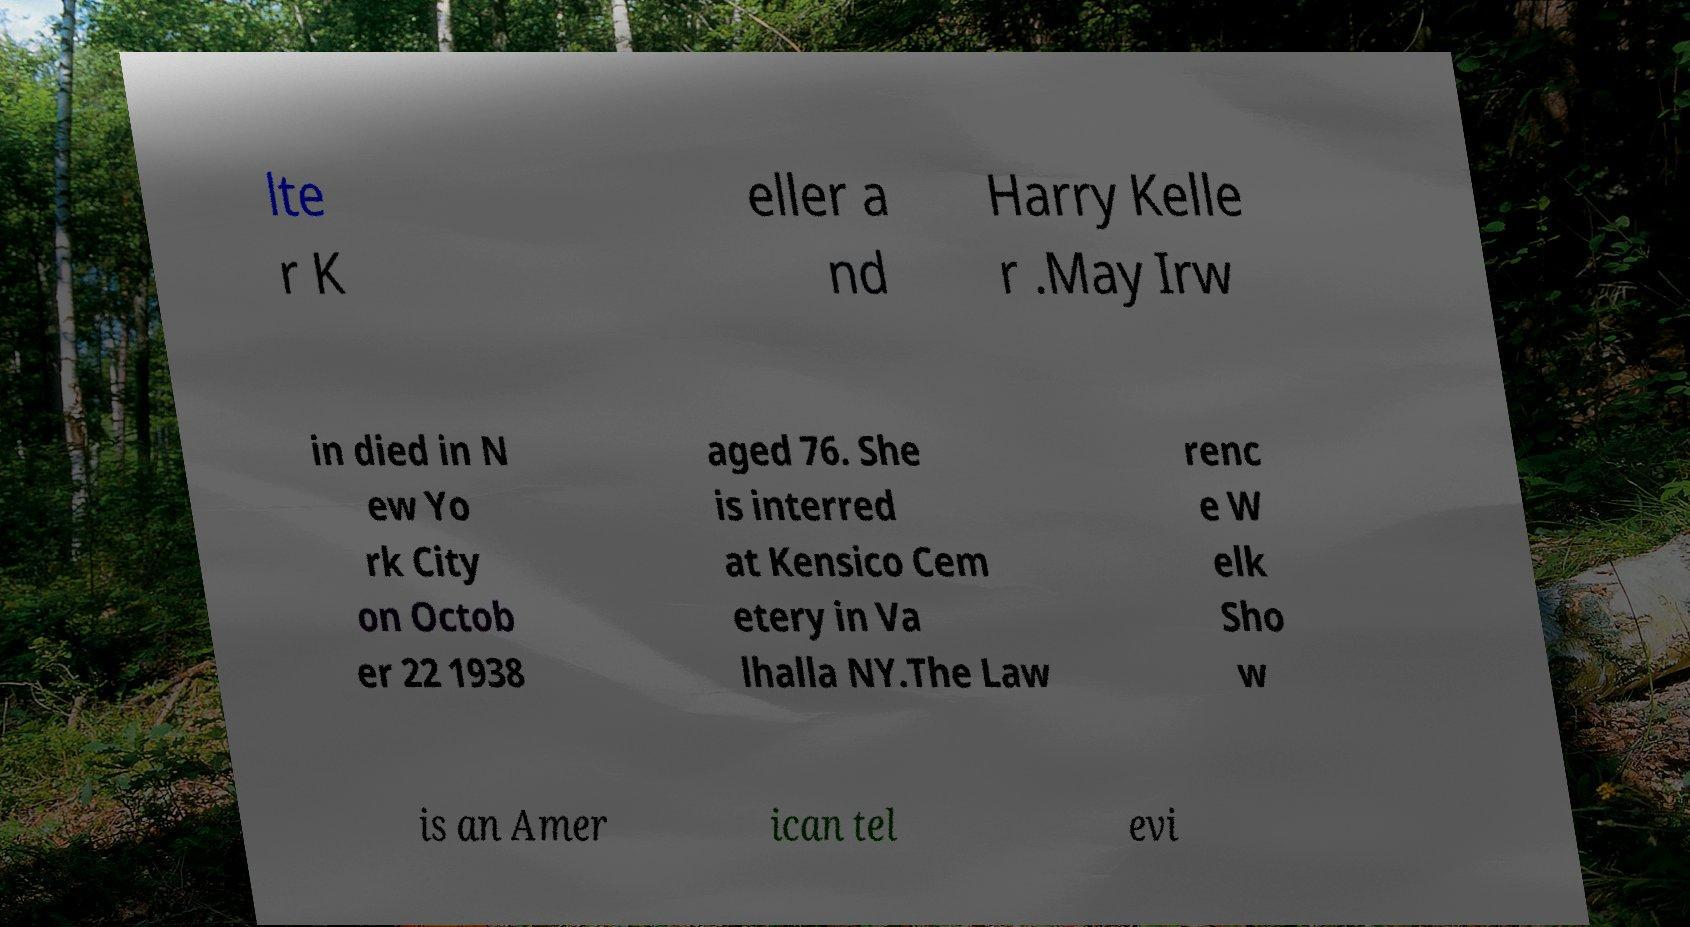What messages or text are displayed in this image? I need them in a readable, typed format. lte r K eller a nd Harry Kelle r .May Irw in died in N ew Yo rk City on Octob er 22 1938 aged 76. She is interred at Kensico Cem etery in Va lhalla NY.The Law renc e W elk Sho w is an Amer ican tel evi 